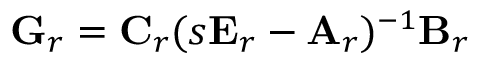Convert formula to latex. <formula><loc_0><loc_0><loc_500><loc_500>G _ { r } = C _ { r } ( s E _ { r } - A _ { r } ) ^ { - 1 } B _ { r }</formula> 